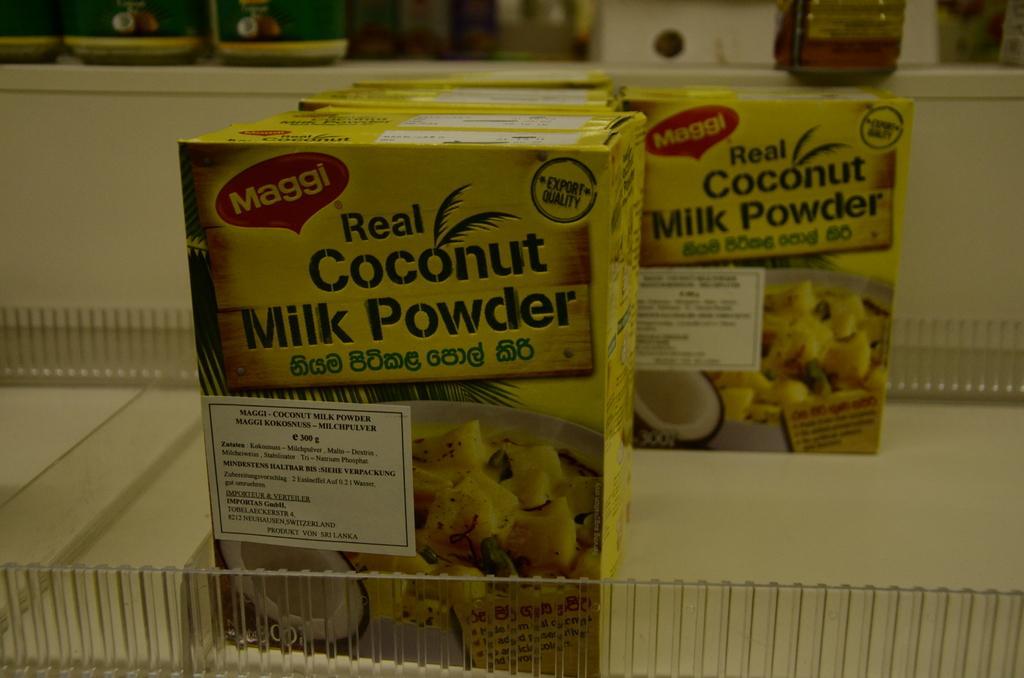How would you summarize this image in a sentence or two? In this image there are coconut powders and few other objects on the table. 